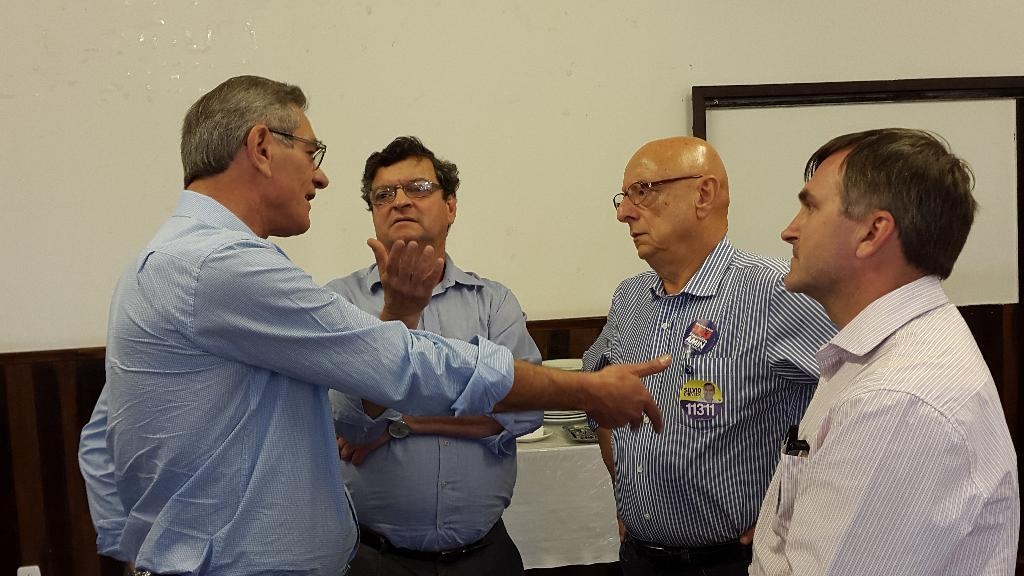How many men are in the image? There are four men in the image. Can you describe one of the men in the image? One of the men is wearing spectacles. What is the man wearing spectacles doing? The man wearing spectacles is talking. What can be seen in the background of the image? There is a wall and a table in the background of the image. What is on the table? There are plates and some objects on the table. How many tails can be seen on the men in the image? There are no tails visible on the men in the image. What type of ear is the beggar wearing in the image? There is no beggar or ear present in the image. 